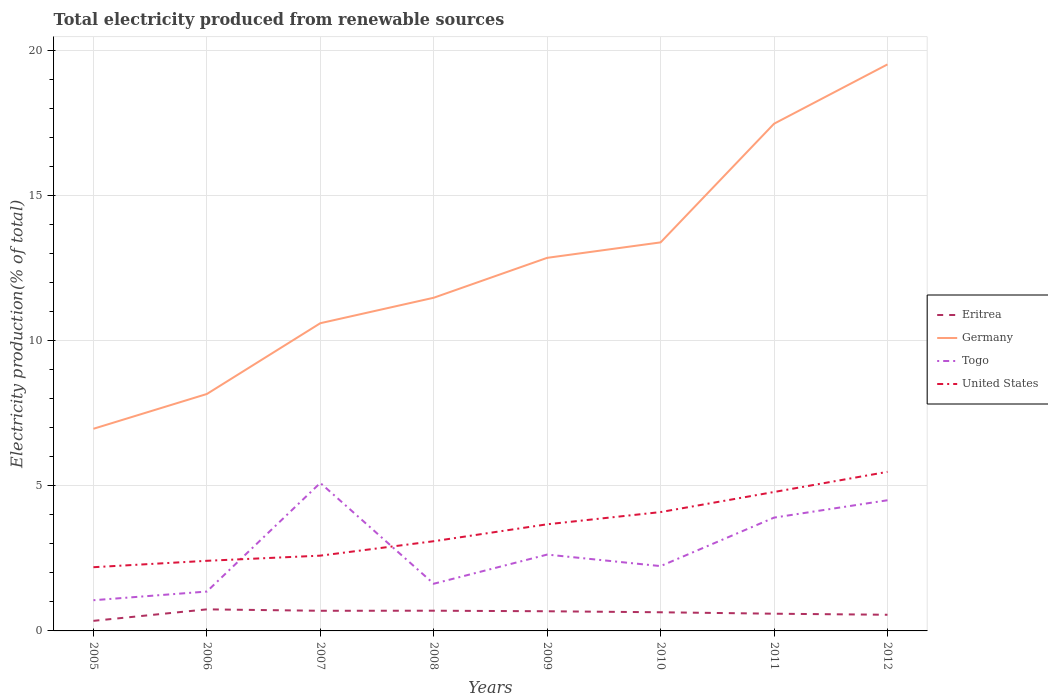Is the number of lines equal to the number of legend labels?
Make the answer very short. Yes. Across all years, what is the maximum total electricity produced in Germany?
Provide a short and direct response. 6.97. What is the total total electricity produced in Eritrea in the graph?
Provide a succinct answer. -0.35. What is the difference between the highest and the second highest total electricity produced in Eritrea?
Offer a terse response. 0.4. How many lines are there?
Ensure brevity in your answer.  4. What is the difference between two consecutive major ticks on the Y-axis?
Your answer should be compact. 5. Are the values on the major ticks of Y-axis written in scientific E-notation?
Provide a short and direct response. No. Does the graph contain any zero values?
Provide a short and direct response. No. How many legend labels are there?
Your answer should be compact. 4. What is the title of the graph?
Ensure brevity in your answer.  Total electricity produced from renewable sources. What is the label or title of the X-axis?
Offer a terse response. Years. What is the label or title of the Y-axis?
Make the answer very short. Electricity production(% of total). What is the Electricity production(% of total) of Eritrea in 2005?
Offer a terse response. 0.35. What is the Electricity production(% of total) in Germany in 2005?
Provide a short and direct response. 6.97. What is the Electricity production(% of total) in Togo in 2005?
Offer a terse response. 1.06. What is the Electricity production(% of total) of United States in 2005?
Offer a very short reply. 2.2. What is the Electricity production(% of total) in Eritrea in 2006?
Offer a very short reply. 0.74. What is the Electricity production(% of total) of Germany in 2006?
Provide a succinct answer. 8.17. What is the Electricity production(% of total) in Togo in 2006?
Ensure brevity in your answer.  1.36. What is the Electricity production(% of total) of United States in 2006?
Make the answer very short. 2.42. What is the Electricity production(% of total) of Eritrea in 2007?
Make the answer very short. 0.69. What is the Electricity production(% of total) of Germany in 2007?
Provide a succinct answer. 10.61. What is the Electricity production(% of total) of Togo in 2007?
Your answer should be very brief. 5.1. What is the Electricity production(% of total) of United States in 2007?
Keep it short and to the point. 2.59. What is the Electricity production(% of total) in Eritrea in 2008?
Ensure brevity in your answer.  0.7. What is the Electricity production(% of total) in Germany in 2008?
Your answer should be compact. 11.49. What is the Electricity production(% of total) in Togo in 2008?
Keep it short and to the point. 1.63. What is the Electricity production(% of total) in United States in 2008?
Keep it short and to the point. 3.09. What is the Electricity production(% of total) in Eritrea in 2009?
Your answer should be very brief. 0.68. What is the Electricity production(% of total) of Germany in 2009?
Provide a short and direct response. 12.86. What is the Electricity production(% of total) in Togo in 2009?
Your answer should be compact. 2.63. What is the Electricity production(% of total) in United States in 2009?
Offer a terse response. 3.68. What is the Electricity production(% of total) of Eritrea in 2010?
Ensure brevity in your answer.  0.64. What is the Electricity production(% of total) of Germany in 2010?
Make the answer very short. 13.39. What is the Electricity production(% of total) in Togo in 2010?
Provide a short and direct response. 2.23. What is the Electricity production(% of total) of United States in 2010?
Make the answer very short. 4.1. What is the Electricity production(% of total) of Eritrea in 2011?
Offer a very short reply. 0.59. What is the Electricity production(% of total) of Germany in 2011?
Offer a terse response. 17.48. What is the Electricity production(% of total) in Togo in 2011?
Your answer should be very brief. 3.91. What is the Electricity production(% of total) in United States in 2011?
Your response must be concise. 4.79. What is the Electricity production(% of total) of Eritrea in 2012?
Your answer should be very brief. 0.56. What is the Electricity production(% of total) of Germany in 2012?
Make the answer very short. 19.53. What is the Electricity production(% of total) of Togo in 2012?
Your answer should be compact. 4.5. What is the Electricity production(% of total) of United States in 2012?
Keep it short and to the point. 5.48. Across all years, what is the maximum Electricity production(% of total) of Eritrea?
Your response must be concise. 0.74. Across all years, what is the maximum Electricity production(% of total) of Germany?
Offer a very short reply. 19.53. Across all years, what is the maximum Electricity production(% of total) in Togo?
Make the answer very short. 5.1. Across all years, what is the maximum Electricity production(% of total) of United States?
Provide a short and direct response. 5.48. Across all years, what is the minimum Electricity production(% of total) in Eritrea?
Ensure brevity in your answer.  0.35. Across all years, what is the minimum Electricity production(% of total) of Germany?
Offer a terse response. 6.97. Across all years, what is the minimum Electricity production(% of total) of Togo?
Your answer should be very brief. 1.06. Across all years, what is the minimum Electricity production(% of total) of United States?
Offer a very short reply. 2.2. What is the total Electricity production(% of total) of Eritrea in the graph?
Make the answer very short. 4.95. What is the total Electricity production(% of total) of Germany in the graph?
Ensure brevity in your answer.  100.5. What is the total Electricity production(% of total) in Togo in the graph?
Provide a short and direct response. 22.42. What is the total Electricity production(% of total) in United States in the graph?
Provide a short and direct response. 28.35. What is the difference between the Electricity production(% of total) in Eritrea in 2005 and that in 2006?
Provide a short and direct response. -0.4. What is the difference between the Electricity production(% of total) of Germany in 2005 and that in 2006?
Offer a very short reply. -1.2. What is the difference between the Electricity production(% of total) in Togo in 2005 and that in 2006?
Ensure brevity in your answer.  -0.3. What is the difference between the Electricity production(% of total) in United States in 2005 and that in 2006?
Offer a terse response. -0.22. What is the difference between the Electricity production(% of total) of Eritrea in 2005 and that in 2007?
Give a very brief answer. -0.35. What is the difference between the Electricity production(% of total) of Germany in 2005 and that in 2007?
Your response must be concise. -3.64. What is the difference between the Electricity production(% of total) of Togo in 2005 and that in 2007?
Your answer should be very brief. -4.04. What is the difference between the Electricity production(% of total) in United States in 2005 and that in 2007?
Provide a short and direct response. -0.4. What is the difference between the Electricity production(% of total) in Eritrea in 2005 and that in 2008?
Provide a short and direct response. -0.35. What is the difference between the Electricity production(% of total) of Germany in 2005 and that in 2008?
Keep it short and to the point. -4.52. What is the difference between the Electricity production(% of total) in Togo in 2005 and that in 2008?
Give a very brief answer. -0.57. What is the difference between the Electricity production(% of total) of United States in 2005 and that in 2008?
Offer a very short reply. -0.9. What is the difference between the Electricity production(% of total) in Eritrea in 2005 and that in 2009?
Offer a very short reply. -0.33. What is the difference between the Electricity production(% of total) of Germany in 2005 and that in 2009?
Make the answer very short. -5.89. What is the difference between the Electricity production(% of total) of Togo in 2005 and that in 2009?
Your answer should be compact. -1.57. What is the difference between the Electricity production(% of total) in United States in 2005 and that in 2009?
Ensure brevity in your answer.  -1.48. What is the difference between the Electricity production(% of total) in Eritrea in 2005 and that in 2010?
Your answer should be very brief. -0.3. What is the difference between the Electricity production(% of total) in Germany in 2005 and that in 2010?
Make the answer very short. -6.43. What is the difference between the Electricity production(% of total) in Togo in 2005 and that in 2010?
Provide a succinct answer. -1.18. What is the difference between the Electricity production(% of total) of United States in 2005 and that in 2010?
Ensure brevity in your answer.  -1.9. What is the difference between the Electricity production(% of total) in Eritrea in 2005 and that in 2011?
Provide a short and direct response. -0.25. What is the difference between the Electricity production(% of total) of Germany in 2005 and that in 2011?
Keep it short and to the point. -10.52. What is the difference between the Electricity production(% of total) of Togo in 2005 and that in 2011?
Make the answer very short. -2.85. What is the difference between the Electricity production(% of total) of United States in 2005 and that in 2011?
Provide a short and direct response. -2.59. What is the difference between the Electricity production(% of total) of Eritrea in 2005 and that in 2012?
Keep it short and to the point. -0.21. What is the difference between the Electricity production(% of total) in Germany in 2005 and that in 2012?
Offer a very short reply. -12.56. What is the difference between the Electricity production(% of total) of Togo in 2005 and that in 2012?
Keep it short and to the point. -3.45. What is the difference between the Electricity production(% of total) of United States in 2005 and that in 2012?
Keep it short and to the point. -3.29. What is the difference between the Electricity production(% of total) of Eritrea in 2006 and that in 2007?
Keep it short and to the point. 0.05. What is the difference between the Electricity production(% of total) in Germany in 2006 and that in 2007?
Offer a very short reply. -2.44. What is the difference between the Electricity production(% of total) of Togo in 2006 and that in 2007?
Ensure brevity in your answer.  -3.74. What is the difference between the Electricity production(% of total) of United States in 2006 and that in 2007?
Offer a very short reply. -0.18. What is the difference between the Electricity production(% of total) of Eritrea in 2006 and that in 2008?
Make the answer very short. 0.05. What is the difference between the Electricity production(% of total) in Germany in 2006 and that in 2008?
Your answer should be very brief. -3.32. What is the difference between the Electricity production(% of total) of Togo in 2006 and that in 2008?
Provide a succinct answer. -0.27. What is the difference between the Electricity production(% of total) in United States in 2006 and that in 2008?
Your answer should be very brief. -0.68. What is the difference between the Electricity production(% of total) of Eritrea in 2006 and that in 2009?
Offer a terse response. 0.07. What is the difference between the Electricity production(% of total) of Germany in 2006 and that in 2009?
Your response must be concise. -4.69. What is the difference between the Electricity production(% of total) in Togo in 2006 and that in 2009?
Give a very brief answer. -1.27. What is the difference between the Electricity production(% of total) in United States in 2006 and that in 2009?
Ensure brevity in your answer.  -1.26. What is the difference between the Electricity production(% of total) in Eritrea in 2006 and that in 2010?
Give a very brief answer. 0.1. What is the difference between the Electricity production(% of total) of Germany in 2006 and that in 2010?
Give a very brief answer. -5.23. What is the difference between the Electricity production(% of total) of Togo in 2006 and that in 2010?
Make the answer very short. -0.88. What is the difference between the Electricity production(% of total) of United States in 2006 and that in 2010?
Give a very brief answer. -1.68. What is the difference between the Electricity production(% of total) of Eritrea in 2006 and that in 2011?
Your answer should be compact. 0.15. What is the difference between the Electricity production(% of total) in Germany in 2006 and that in 2011?
Keep it short and to the point. -9.32. What is the difference between the Electricity production(% of total) of Togo in 2006 and that in 2011?
Offer a very short reply. -2.55. What is the difference between the Electricity production(% of total) in United States in 2006 and that in 2011?
Offer a terse response. -2.37. What is the difference between the Electricity production(% of total) in Eritrea in 2006 and that in 2012?
Your response must be concise. 0.19. What is the difference between the Electricity production(% of total) in Germany in 2006 and that in 2012?
Keep it short and to the point. -11.36. What is the difference between the Electricity production(% of total) of Togo in 2006 and that in 2012?
Make the answer very short. -3.15. What is the difference between the Electricity production(% of total) of United States in 2006 and that in 2012?
Offer a very short reply. -3.07. What is the difference between the Electricity production(% of total) in Eritrea in 2007 and that in 2008?
Keep it short and to the point. -0. What is the difference between the Electricity production(% of total) of Germany in 2007 and that in 2008?
Keep it short and to the point. -0.88. What is the difference between the Electricity production(% of total) in Togo in 2007 and that in 2008?
Give a very brief answer. 3.48. What is the difference between the Electricity production(% of total) of United States in 2007 and that in 2008?
Give a very brief answer. -0.5. What is the difference between the Electricity production(% of total) in Eritrea in 2007 and that in 2009?
Your response must be concise. 0.02. What is the difference between the Electricity production(% of total) of Germany in 2007 and that in 2009?
Provide a short and direct response. -2.25. What is the difference between the Electricity production(% of total) in Togo in 2007 and that in 2009?
Your response must be concise. 2.47. What is the difference between the Electricity production(% of total) of United States in 2007 and that in 2009?
Keep it short and to the point. -1.08. What is the difference between the Electricity production(% of total) of Eritrea in 2007 and that in 2010?
Your answer should be compact. 0.05. What is the difference between the Electricity production(% of total) of Germany in 2007 and that in 2010?
Your response must be concise. -2.79. What is the difference between the Electricity production(% of total) of Togo in 2007 and that in 2010?
Provide a short and direct response. 2.87. What is the difference between the Electricity production(% of total) in United States in 2007 and that in 2010?
Your answer should be very brief. -1.5. What is the difference between the Electricity production(% of total) in Eritrea in 2007 and that in 2011?
Give a very brief answer. 0.1. What is the difference between the Electricity production(% of total) of Germany in 2007 and that in 2011?
Make the answer very short. -6.88. What is the difference between the Electricity production(% of total) in Togo in 2007 and that in 2011?
Provide a succinct answer. 1.2. What is the difference between the Electricity production(% of total) in United States in 2007 and that in 2011?
Keep it short and to the point. -2.19. What is the difference between the Electricity production(% of total) in Eritrea in 2007 and that in 2012?
Offer a terse response. 0.14. What is the difference between the Electricity production(% of total) of Germany in 2007 and that in 2012?
Keep it short and to the point. -8.92. What is the difference between the Electricity production(% of total) of Togo in 2007 and that in 2012?
Give a very brief answer. 0.6. What is the difference between the Electricity production(% of total) of United States in 2007 and that in 2012?
Make the answer very short. -2.89. What is the difference between the Electricity production(% of total) of Eritrea in 2008 and that in 2009?
Offer a very short reply. 0.02. What is the difference between the Electricity production(% of total) in Germany in 2008 and that in 2009?
Offer a very short reply. -1.38. What is the difference between the Electricity production(% of total) of Togo in 2008 and that in 2009?
Give a very brief answer. -1.01. What is the difference between the Electricity production(% of total) of United States in 2008 and that in 2009?
Keep it short and to the point. -0.58. What is the difference between the Electricity production(% of total) in Eritrea in 2008 and that in 2010?
Your answer should be compact. 0.05. What is the difference between the Electricity production(% of total) of Germany in 2008 and that in 2010?
Your answer should be very brief. -1.91. What is the difference between the Electricity production(% of total) in Togo in 2008 and that in 2010?
Provide a short and direct response. -0.61. What is the difference between the Electricity production(% of total) in United States in 2008 and that in 2010?
Offer a very short reply. -1. What is the difference between the Electricity production(% of total) in Eritrea in 2008 and that in 2011?
Your answer should be very brief. 0.1. What is the difference between the Electricity production(% of total) in Germany in 2008 and that in 2011?
Your answer should be very brief. -6. What is the difference between the Electricity production(% of total) of Togo in 2008 and that in 2011?
Offer a very short reply. -2.28. What is the difference between the Electricity production(% of total) of United States in 2008 and that in 2011?
Offer a terse response. -1.7. What is the difference between the Electricity production(% of total) in Eritrea in 2008 and that in 2012?
Ensure brevity in your answer.  0.14. What is the difference between the Electricity production(% of total) of Germany in 2008 and that in 2012?
Ensure brevity in your answer.  -8.04. What is the difference between the Electricity production(% of total) in Togo in 2008 and that in 2012?
Offer a terse response. -2.88. What is the difference between the Electricity production(% of total) of United States in 2008 and that in 2012?
Your response must be concise. -2.39. What is the difference between the Electricity production(% of total) in Eritrea in 2009 and that in 2010?
Offer a very short reply. 0.03. What is the difference between the Electricity production(% of total) in Germany in 2009 and that in 2010?
Your answer should be very brief. -0.53. What is the difference between the Electricity production(% of total) of Togo in 2009 and that in 2010?
Offer a terse response. 0.4. What is the difference between the Electricity production(% of total) in United States in 2009 and that in 2010?
Your answer should be compact. -0.42. What is the difference between the Electricity production(% of total) in Eritrea in 2009 and that in 2011?
Offer a terse response. 0.08. What is the difference between the Electricity production(% of total) of Germany in 2009 and that in 2011?
Your answer should be very brief. -4.62. What is the difference between the Electricity production(% of total) in Togo in 2009 and that in 2011?
Provide a succinct answer. -1.27. What is the difference between the Electricity production(% of total) in United States in 2009 and that in 2011?
Offer a very short reply. -1.11. What is the difference between the Electricity production(% of total) in Eritrea in 2009 and that in 2012?
Provide a succinct answer. 0.12. What is the difference between the Electricity production(% of total) of Germany in 2009 and that in 2012?
Provide a succinct answer. -6.67. What is the difference between the Electricity production(% of total) of Togo in 2009 and that in 2012?
Ensure brevity in your answer.  -1.87. What is the difference between the Electricity production(% of total) of United States in 2009 and that in 2012?
Your answer should be very brief. -1.81. What is the difference between the Electricity production(% of total) in Eritrea in 2010 and that in 2011?
Offer a terse response. 0.05. What is the difference between the Electricity production(% of total) in Germany in 2010 and that in 2011?
Make the answer very short. -4.09. What is the difference between the Electricity production(% of total) of Togo in 2010 and that in 2011?
Offer a very short reply. -1.67. What is the difference between the Electricity production(% of total) in United States in 2010 and that in 2011?
Offer a terse response. -0.69. What is the difference between the Electricity production(% of total) of Eritrea in 2010 and that in 2012?
Ensure brevity in your answer.  0.09. What is the difference between the Electricity production(% of total) in Germany in 2010 and that in 2012?
Offer a terse response. -6.14. What is the difference between the Electricity production(% of total) in Togo in 2010 and that in 2012?
Ensure brevity in your answer.  -2.27. What is the difference between the Electricity production(% of total) in United States in 2010 and that in 2012?
Offer a terse response. -1.39. What is the difference between the Electricity production(% of total) in Eritrea in 2011 and that in 2012?
Offer a terse response. 0.04. What is the difference between the Electricity production(% of total) of Germany in 2011 and that in 2012?
Your response must be concise. -2.05. What is the difference between the Electricity production(% of total) of Togo in 2011 and that in 2012?
Give a very brief answer. -0.6. What is the difference between the Electricity production(% of total) in United States in 2011 and that in 2012?
Provide a succinct answer. -0.69. What is the difference between the Electricity production(% of total) in Eritrea in 2005 and the Electricity production(% of total) in Germany in 2006?
Your answer should be very brief. -7.82. What is the difference between the Electricity production(% of total) in Eritrea in 2005 and the Electricity production(% of total) in Togo in 2006?
Your answer should be very brief. -1.01. What is the difference between the Electricity production(% of total) in Eritrea in 2005 and the Electricity production(% of total) in United States in 2006?
Make the answer very short. -2.07. What is the difference between the Electricity production(% of total) in Germany in 2005 and the Electricity production(% of total) in Togo in 2006?
Keep it short and to the point. 5.61. What is the difference between the Electricity production(% of total) in Germany in 2005 and the Electricity production(% of total) in United States in 2006?
Offer a very short reply. 4.55. What is the difference between the Electricity production(% of total) in Togo in 2005 and the Electricity production(% of total) in United States in 2006?
Your answer should be very brief. -1.36. What is the difference between the Electricity production(% of total) in Eritrea in 2005 and the Electricity production(% of total) in Germany in 2007?
Your answer should be compact. -10.26. What is the difference between the Electricity production(% of total) of Eritrea in 2005 and the Electricity production(% of total) of Togo in 2007?
Your answer should be very brief. -4.75. What is the difference between the Electricity production(% of total) of Eritrea in 2005 and the Electricity production(% of total) of United States in 2007?
Your answer should be compact. -2.25. What is the difference between the Electricity production(% of total) in Germany in 2005 and the Electricity production(% of total) in Togo in 2007?
Ensure brevity in your answer.  1.87. What is the difference between the Electricity production(% of total) in Germany in 2005 and the Electricity production(% of total) in United States in 2007?
Keep it short and to the point. 4.37. What is the difference between the Electricity production(% of total) of Togo in 2005 and the Electricity production(% of total) of United States in 2007?
Provide a succinct answer. -1.54. What is the difference between the Electricity production(% of total) in Eritrea in 2005 and the Electricity production(% of total) in Germany in 2008?
Give a very brief answer. -11.14. What is the difference between the Electricity production(% of total) in Eritrea in 2005 and the Electricity production(% of total) in Togo in 2008?
Offer a very short reply. -1.28. What is the difference between the Electricity production(% of total) in Eritrea in 2005 and the Electricity production(% of total) in United States in 2008?
Give a very brief answer. -2.75. What is the difference between the Electricity production(% of total) in Germany in 2005 and the Electricity production(% of total) in Togo in 2008?
Make the answer very short. 5.34. What is the difference between the Electricity production(% of total) of Germany in 2005 and the Electricity production(% of total) of United States in 2008?
Make the answer very short. 3.88. What is the difference between the Electricity production(% of total) of Togo in 2005 and the Electricity production(% of total) of United States in 2008?
Offer a terse response. -2.03. What is the difference between the Electricity production(% of total) in Eritrea in 2005 and the Electricity production(% of total) in Germany in 2009?
Your response must be concise. -12.51. What is the difference between the Electricity production(% of total) in Eritrea in 2005 and the Electricity production(% of total) in Togo in 2009?
Make the answer very short. -2.28. What is the difference between the Electricity production(% of total) of Eritrea in 2005 and the Electricity production(% of total) of United States in 2009?
Your response must be concise. -3.33. What is the difference between the Electricity production(% of total) in Germany in 2005 and the Electricity production(% of total) in Togo in 2009?
Make the answer very short. 4.34. What is the difference between the Electricity production(% of total) in Germany in 2005 and the Electricity production(% of total) in United States in 2009?
Offer a very short reply. 3.29. What is the difference between the Electricity production(% of total) of Togo in 2005 and the Electricity production(% of total) of United States in 2009?
Offer a very short reply. -2.62. What is the difference between the Electricity production(% of total) of Eritrea in 2005 and the Electricity production(% of total) of Germany in 2010?
Make the answer very short. -13.05. What is the difference between the Electricity production(% of total) of Eritrea in 2005 and the Electricity production(% of total) of Togo in 2010?
Keep it short and to the point. -1.89. What is the difference between the Electricity production(% of total) in Eritrea in 2005 and the Electricity production(% of total) in United States in 2010?
Your response must be concise. -3.75. What is the difference between the Electricity production(% of total) in Germany in 2005 and the Electricity production(% of total) in Togo in 2010?
Your answer should be compact. 4.73. What is the difference between the Electricity production(% of total) of Germany in 2005 and the Electricity production(% of total) of United States in 2010?
Keep it short and to the point. 2.87. What is the difference between the Electricity production(% of total) of Togo in 2005 and the Electricity production(% of total) of United States in 2010?
Ensure brevity in your answer.  -3.04. What is the difference between the Electricity production(% of total) of Eritrea in 2005 and the Electricity production(% of total) of Germany in 2011?
Offer a very short reply. -17.14. What is the difference between the Electricity production(% of total) in Eritrea in 2005 and the Electricity production(% of total) in Togo in 2011?
Provide a succinct answer. -3.56. What is the difference between the Electricity production(% of total) of Eritrea in 2005 and the Electricity production(% of total) of United States in 2011?
Make the answer very short. -4.44. What is the difference between the Electricity production(% of total) in Germany in 2005 and the Electricity production(% of total) in Togo in 2011?
Provide a short and direct response. 3.06. What is the difference between the Electricity production(% of total) of Germany in 2005 and the Electricity production(% of total) of United States in 2011?
Your answer should be compact. 2.18. What is the difference between the Electricity production(% of total) in Togo in 2005 and the Electricity production(% of total) in United States in 2011?
Provide a short and direct response. -3.73. What is the difference between the Electricity production(% of total) of Eritrea in 2005 and the Electricity production(% of total) of Germany in 2012?
Offer a very short reply. -19.18. What is the difference between the Electricity production(% of total) in Eritrea in 2005 and the Electricity production(% of total) in Togo in 2012?
Keep it short and to the point. -4.16. What is the difference between the Electricity production(% of total) in Eritrea in 2005 and the Electricity production(% of total) in United States in 2012?
Your answer should be compact. -5.14. What is the difference between the Electricity production(% of total) of Germany in 2005 and the Electricity production(% of total) of Togo in 2012?
Make the answer very short. 2.46. What is the difference between the Electricity production(% of total) of Germany in 2005 and the Electricity production(% of total) of United States in 2012?
Give a very brief answer. 1.48. What is the difference between the Electricity production(% of total) in Togo in 2005 and the Electricity production(% of total) in United States in 2012?
Provide a short and direct response. -4.43. What is the difference between the Electricity production(% of total) of Eritrea in 2006 and the Electricity production(% of total) of Germany in 2007?
Your answer should be very brief. -9.86. What is the difference between the Electricity production(% of total) of Eritrea in 2006 and the Electricity production(% of total) of Togo in 2007?
Give a very brief answer. -4.36. What is the difference between the Electricity production(% of total) of Eritrea in 2006 and the Electricity production(% of total) of United States in 2007?
Offer a very short reply. -1.85. What is the difference between the Electricity production(% of total) of Germany in 2006 and the Electricity production(% of total) of Togo in 2007?
Keep it short and to the point. 3.07. What is the difference between the Electricity production(% of total) of Germany in 2006 and the Electricity production(% of total) of United States in 2007?
Your response must be concise. 5.57. What is the difference between the Electricity production(% of total) of Togo in 2006 and the Electricity production(% of total) of United States in 2007?
Your answer should be very brief. -1.24. What is the difference between the Electricity production(% of total) in Eritrea in 2006 and the Electricity production(% of total) in Germany in 2008?
Ensure brevity in your answer.  -10.74. What is the difference between the Electricity production(% of total) of Eritrea in 2006 and the Electricity production(% of total) of Togo in 2008?
Keep it short and to the point. -0.88. What is the difference between the Electricity production(% of total) of Eritrea in 2006 and the Electricity production(% of total) of United States in 2008?
Ensure brevity in your answer.  -2.35. What is the difference between the Electricity production(% of total) of Germany in 2006 and the Electricity production(% of total) of Togo in 2008?
Your answer should be very brief. 6.54. What is the difference between the Electricity production(% of total) of Germany in 2006 and the Electricity production(% of total) of United States in 2008?
Keep it short and to the point. 5.08. What is the difference between the Electricity production(% of total) in Togo in 2006 and the Electricity production(% of total) in United States in 2008?
Offer a very short reply. -1.74. What is the difference between the Electricity production(% of total) of Eritrea in 2006 and the Electricity production(% of total) of Germany in 2009?
Offer a terse response. -12.12. What is the difference between the Electricity production(% of total) in Eritrea in 2006 and the Electricity production(% of total) in Togo in 2009?
Provide a short and direct response. -1.89. What is the difference between the Electricity production(% of total) of Eritrea in 2006 and the Electricity production(% of total) of United States in 2009?
Your response must be concise. -2.93. What is the difference between the Electricity production(% of total) of Germany in 2006 and the Electricity production(% of total) of Togo in 2009?
Give a very brief answer. 5.54. What is the difference between the Electricity production(% of total) of Germany in 2006 and the Electricity production(% of total) of United States in 2009?
Your answer should be compact. 4.49. What is the difference between the Electricity production(% of total) of Togo in 2006 and the Electricity production(% of total) of United States in 2009?
Your response must be concise. -2.32. What is the difference between the Electricity production(% of total) of Eritrea in 2006 and the Electricity production(% of total) of Germany in 2010?
Provide a succinct answer. -12.65. What is the difference between the Electricity production(% of total) in Eritrea in 2006 and the Electricity production(% of total) in Togo in 2010?
Your answer should be compact. -1.49. What is the difference between the Electricity production(% of total) of Eritrea in 2006 and the Electricity production(% of total) of United States in 2010?
Give a very brief answer. -3.35. What is the difference between the Electricity production(% of total) of Germany in 2006 and the Electricity production(% of total) of Togo in 2010?
Your answer should be very brief. 5.93. What is the difference between the Electricity production(% of total) in Germany in 2006 and the Electricity production(% of total) in United States in 2010?
Offer a very short reply. 4.07. What is the difference between the Electricity production(% of total) of Togo in 2006 and the Electricity production(% of total) of United States in 2010?
Offer a terse response. -2.74. What is the difference between the Electricity production(% of total) of Eritrea in 2006 and the Electricity production(% of total) of Germany in 2011?
Keep it short and to the point. -16.74. What is the difference between the Electricity production(% of total) in Eritrea in 2006 and the Electricity production(% of total) in Togo in 2011?
Your response must be concise. -3.16. What is the difference between the Electricity production(% of total) of Eritrea in 2006 and the Electricity production(% of total) of United States in 2011?
Provide a succinct answer. -4.05. What is the difference between the Electricity production(% of total) of Germany in 2006 and the Electricity production(% of total) of Togo in 2011?
Make the answer very short. 4.26. What is the difference between the Electricity production(% of total) of Germany in 2006 and the Electricity production(% of total) of United States in 2011?
Offer a terse response. 3.38. What is the difference between the Electricity production(% of total) of Togo in 2006 and the Electricity production(% of total) of United States in 2011?
Your answer should be very brief. -3.43. What is the difference between the Electricity production(% of total) in Eritrea in 2006 and the Electricity production(% of total) in Germany in 2012?
Your response must be concise. -18.79. What is the difference between the Electricity production(% of total) of Eritrea in 2006 and the Electricity production(% of total) of Togo in 2012?
Offer a terse response. -3.76. What is the difference between the Electricity production(% of total) in Eritrea in 2006 and the Electricity production(% of total) in United States in 2012?
Your answer should be very brief. -4.74. What is the difference between the Electricity production(% of total) of Germany in 2006 and the Electricity production(% of total) of Togo in 2012?
Give a very brief answer. 3.66. What is the difference between the Electricity production(% of total) of Germany in 2006 and the Electricity production(% of total) of United States in 2012?
Ensure brevity in your answer.  2.68. What is the difference between the Electricity production(% of total) in Togo in 2006 and the Electricity production(% of total) in United States in 2012?
Give a very brief answer. -4.13. What is the difference between the Electricity production(% of total) of Eritrea in 2007 and the Electricity production(% of total) of Germany in 2008?
Your response must be concise. -10.79. What is the difference between the Electricity production(% of total) in Eritrea in 2007 and the Electricity production(% of total) in Togo in 2008?
Provide a short and direct response. -0.93. What is the difference between the Electricity production(% of total) in Eritrea in 2007 and the Electricity production(% of total) in United States in 2008?
Your answer should be very brief. -2.4. What is the difference between the Electricity production(% of total) in Germany in 2007 and the Electricity production(% of total) in Togo in 2008?
Your response must be concise. 8.98. What is the difference between the Electricity production(% of total) in Germany in 2007 and the Electricity production(% of total) in United States in 2008?
Offer a terse response. 7.52. What is the difference between the Electricity production(% of total) of Togo in 2007 and the Electricity production(% of total) of United States in 2008?
Keep it short and to the point. 2.01. What is the difference between the Electricity production(% of total) in Eritrea in 2007 and the Electricity production(% of total) in Germany in 2009?
Offer a very short reply. -12.17. What is the difference between the Electricity production(% of total) in Eritrea in 2007 and the Electricity production(% of total) in Togo in 2009?
Make the answer very short. -1.94. What is the difference between the Electricity production(% of total) of Eritrea in 2007 and the Electricity production(% of total) of United States in 2009?
Offer a terse response. -2.98. What is the difference between the Electricity production(% of total) in Germany in 2007 and the Electricity production(% of total) in Togo in 2009?
Your answer should be compact. 7.98. What is the difference between the Electricity production(% of total) of Germany in 2007 and the Electricity production(% of total) of United States in 2009?
Your response must be concise. 6.93. What is the difference between the Electricity production(% of total) in Togo in 2007 and the Electricity production(% of total) in United States in 2009?
Your answer should be very brief. 1.43. What is the difference between the Electricity production(% of total) of Eritrea in 2007 and the Electricity production(% of total) of Germany in 2010?
Give a very brief answer. -12.7. What is the difference between the Electricity production(% of total) in Eritrea in 2007 and the Electricity production(% of total) in Togo in 2010?
Offer a terse response. -1.54. What is the difference between the Electricity production(% of total) of Eritrea in 2007 and the Electricity production(% of total) of United States in 2010?
Make the answer very short. -3.4. What is the difference between the Electricity production(% of total) of Germany in 2007 and the Electricity production(% of total) of Togo in 2010?
Your answer should be very brief. 8.37. What is the difference between the Electricity production(% of total) in Germany in 2007 and the Electricity production(% of total) in United States in 2010?
Ensure brevity in your answer.  6.51. What is the difference between the Electricity production(% of total) in Togo in 2007 and the Electricity production(% of total) in United States in 2010?
Your response must be concise. 1. What is the difference between the Electricity production(% of total) in Eritrea in 2007 and the Electricity production(% of total) in Germany in 2011?
Your response must be concise. -16.79. What is the difference between the Electricity production(% of total) of Eritrea in 2007 and the Electricity production(% of total) of Togo in 2011?
Offer a terse response. -3.21. What is the difference between the Electricity production(% of total) of Eritrea in 2007 and the Electricity production(% of total) of United States in 2011?
Offer a terse response. -4.09. What is the difference between the Electricity production(% of total) in Germany in 2007 and the Electricity production(% of total) in Togo in 2011?
Make the answer very short. 6.7. What is the difference between the Electricity production(% of total) in Germany in 2007 and the Electricity production(% of total) in United States in 2011?
Offer a terse response. 5.82. What is the difference between the Electricity production(% of total) in Togo in 2007 and the Electricity production(% of total) in United States in 2011?
Make the answer very short. 0.31. What is the difference between the Electricity production(% of total) of Eritrea in 2007 and the Electricity production(% of total) of Germany in 2012?
Give a very brief answer. -18.84. What is the difference between the Electricity production(% of total) of Eritrea in 2007 and the Electricity production(% of total) of Togo in 2012?
Make the answer very short. -3.81. What is the difference between the Electricity production(% of total) in Eritrea in 2007 and the Electricity production(% of total) in United States in 2012?
Your answer should be compact. -4.79. What is the difference between the Electricity production(% of total) in Germany in 2007 and the Electricity production(% of total) in Togo in 2012?
Offer a very short reply. 6.1. What is the difference between the Electricity production(% of total) of Germany in 2007 and the Electricity production(% of total) of United States in 2012?
Your response must be concise. 5.12. What is the difference between the Electricity production(% of total) of Togo in 2007 and the Electricity production(% of total) of United States in 2012?
Your response must be concise. -0.38. What is the difference between the Electricity production(% of total) of Eritrea in 2008 and the Electricity production(% of total) of Germany in 2009?
Keep it short and to the point. -12.16. What is the difference between the Electricity production(% of total) of Eritrea in 2008 and the Electricity production(% of total) of Togo in 2009?
Your answer should be compact. -1.93. What is the difference between the Electricity production(% of total) in Eritrea in 2008 and the Electricity production(% of total) in United States in 2009?
Offer a terse response. -2.98. What is the difference between the Electricity production(% of total) of Germany in 2008 and the Electricity production(% of total) of Togo in 2009?
Make the answer very short. 8.85. What is the difference between the Electricity production(% of total) in Germany in 2008 and the Electricity production(% of total) in United States in 2009?
Provide a succinct answer. 7.81. What is the difference between the Electricity production(% of total) of Togo in 2008 and the Electricity production(% of total) of United States in 2009?
Provide a succinct answer. -2.05. What is the difference between the Electricity production(% of total) in Eritrea in 2008 and the Electricity production(% of total) in Germany in 2010?
Ensure brevity in your answer.  -12.7. What is the difference between the Electricity production(% of total) in Eritrea in 2008 and the Electricity production(% of total) in Togo in 2010?
Your response must be concise. -1.54. What is the difference between the Electricity production(% of total) of Eritrea in 2008 and the Electricity production(% of total) of United States in 2010?
Provide a short and direct response. -3.4. What is the difference between the Electricity production(% of total) of Germany in 2008 and the Electricity production(% of total) of Togo in 2010?
Offer a very short reply. 9.25. What is the difference between the Electricity production(% of total) in Germany in 2008 and the Electricity production(% of total) in United States in 2010?
Ensure brevity in your answer.  7.39. What is the difference between the Electricity production(% of total) in Togo in 2008 and the Electricity production(% of total) in United States in 2010?
Offer a very short reply. -2.47. What is the difference between the Electricity production(% of total) in Eritrea in 2008 and the Electricity production(% of total) in Germany in 2011?
Ensure brevity in your answer.  -16.79. What is the difference between the Electricity production(% of total) of Eritrea in 2008 and the Electricity production(% of total) of Togo in 2011?
Your answer should be compact. -3.21. What is the difference between the Electricity production(% of total) of Eritrea in 2008 and the Electricity production(% of total) of United States in 2011?
Provide a succinct answer. -4.09. What is the difference between the Electricity production(% of total) of Germany in 2008 and the Electricity production(% of total) of Togo in 2011?
Make the answer very short. 7.58. What is the difference between the Electricity production(% of total) of Germany in 2008 and the Electricity production(% of total) of United States in 2011?
Provide a succinct answer. 6.7. What is the difference between the Electricity production(% of total) in Togo in 2008 and the Electricity production(% of total) in United States in 2011?
Offer a terse response. -3.16. What is the difference between the Electricity production(% of total) of Eritrea in 2008 and the Electricity production(% of total) of Germany in 2012?
Offer a terse response. -18.83. What is the difference between the Electricity production(% of total) in Eritrea in 2008 and the Electricity production(% of total) in Togo in 2012?
Offer a terse response. -3.81. What is the difference between the Electricity production(% of total) of Eritrea in 2008 and the Electricity production(% of total) of United States in 2012?
Make the answer very short. -4.79. What is the difference between the Electricity production(% of total) in Germany in 2008 and the Electricity production(% of total) in Togo in 2012?
Keep it short and to the point. 6.98. What is the difference between the Electricity production(% of total) of Germany in 2008 and the Electricity production(% of total) of United States in 2012?
Your answer should be compact. 6. What is the difference between the Electricity production(% of total) in Togo in 2008 and the Electricity production(% of total) in United States in 2012?
Provide a short and direct response. -3.86. What is the difference between the Electricity production(% of total) of Eritrea in 2009 and the Electricity production(% of total) of Germany in 2010?
Provide a short and direct response. -12.72. What is the difference between the Electricity production(% of total) in Eritrea in 2009 and the Electricity production(% of total) in Togo in 2010?
Ensure brevity in your answer.  -1.56. What is the difference between the Electricity production(% of total) of Eritrea in 2009 and the Electricity production(% of total) of United States in 2010?
Keep it short and to the point. -3.42. What is the difference between the Electricity production(% of total) of Germany in 2009 and the Electricity production(% of total) of Togo in 2010?
Ensure brevity in your answer.  10.63. What is the difference between the Electricity production(% of total) of Germany in 2009 and the Electricity production(% of total) of United States in 2010?
Ensure brevity in your answer.  8.76. What is the difference between the Electricity production(% of total) of Togo in 2009 and the Electricity production(% of total) of United States in 2010?
Offer a terse response. -1.47. What is the difference between the Electricity production(% of total) of Eritrea in 2009 and the Electricity production(% of total) of Germany in 2011?
Keep it short and to the point. -16.81. What is the difference between the Electricity production(% of total) of Eritrea in 2009 and the Electricity production(% of total) of Togo in 2011?
Offer a very short reply. -3.23. What is the difference between the Electricity production(% of total) of Eritrea in 2009 and the Electricity production(% of total) of United States in 2011?
Provide a short and direct response. -4.11. What is the difference between the Electricity production(% of total) of Germany in 2009 and the Electricity production(% of total) of Togo in 2011?
Your response must be concise. 8.96. What is the difference between the Electricity production(% of total) of Germany in 2009 and the Electricity production(% of total) of United States in 2011?
Keep it short and to the point. 8.07. What is the difference between the Electricity production(% of total) of Togo in 2009 and the Electricity production(% of total) of United States in 2011?
Your answer should be compact. -2.16. What is the difference between the Electricity production(% of total) in Eritrea in 2009 and the Electricity production(% of total) in Germany in 2012?
Your answer should be compact. -18.85. What is the difference between the Electricity production(% of total) of Eritrea in 2009 and the Electricity production(% of total) of Togo in 2012?
Your answer should be very brief. -3.83. What is the difference between the Electricity production(% of total) in Eritrea in 2009 and the Electricity production(% of total) in United States in 2012?
Ensure brevity in your answer.  -4.81. What is the difference between the Electricity production(% of total) of Germany in 2009 and the Electricity production(% of total) of Togo in 2012?
Keep it short and to the point. 8.36. What is the difference between the Electricity production(% of total) of Germany in 2009 and the Electricity production(% of total) of United States in 2012?
Your answer should be compact. 7.38. What is the difference between the Electricity production(% of total) in Togo in 2009 and the Electricity production(% of total) in United States in 2012?
Keep it short and to the point. -2.85. What is the difference between the Electricity production(% of total) in Eritrea in 2010 and the Electricity production(% of total) in Germany in 2011?
Your response must be concise. -16.84. What is the difference between the Electricity production(% of total) of Eritrea in 2010 and the Electricity production(% of total) of Togo in 2011?
Give a very brief answer. -3.26. What is the difference between the Electricity production(% of total) in Eritrea in 2010 and the Electricity production(% of total) in United States in 2011?
Offer a very short reply. -4.15. What is the difference between the Electricity production(% of total) in Germany in 2010 and the Electricity production(% of total) in Togo in 2011?
Give a very brief answer. 9.49. What is the difference between the Electricity production(% of total) of Germany in 2010 and the Electricity production(% of total) of United States in 2011?
Provide a succinct answer. 8.61. What is the difference between the Electricity production(% of total) in Togo in 2010 and the Electricity production(% of total) in United States in 2011?
Keep it short and to the point. -2.55. What is the difference between the Electricity production(% of total) in Eritrea in 2010 and the Electricity production(% of total) in Germany in 2012?
Offer a very short reply. -18.89. What is the difference between the Electricity production(% of total) of Eritrea in 2010 and the Electricity production(% of total) of Togo in 2012?
Your answer should be compact. -3.86. What is the difference between the Electricity production(% of total) in Eritrea in 2010 and the Electricity production(% of total) in United States in 2012?
Provide a short and direct response. -4.84. What is the difference between the Electricity production(% of total) in Germany in 2010 and the Electricity production(% of total) in Togo in 2012?
Offer a very short reply. 8.89. What is the difference between the Electricity production(% of total) in Germany in 2010 and the Electricity production(% of total) in United States in 2012?
Your answer should be compact. 7.91. What is the difference between the Electricity production(% of total) in Togo in 2010 and the Electricity production(% of total) in United States in 2012?
Ensure brevity in your answer.  -3.25. What is the difference between the Electricity production(% of total) in Eritrea in 2011 and the Electricity production(% of total) in Germany in 2012?
Offer a terse response. -18.94. What is the difference between the Electricity production(% of total) in Eritrea in 2011 and the Electricity production(% of total) in Togo in 2012?
Ensure brevity in your answer.  -3.91. What is the difference between the Electricity production(% of total) in Eritrea in 2011 and the Electricity production(% of total) in United States in 2012?
Provide a short and direct response. -4.89. What is the difference between the Electricity production(% of total) of Germany in 2011 and the Electricity production(% of total) of Togo in 2012?
Your response must be concise. 12.98. What is the difference between the Electricity production(% of total) of Germany in 2011 and the Electricity production(% of total) of United States in 2012?
Ensure brevity in your answer.  12. What is the difference between the Electricity production(% of total) of Togo in 2011 and the Electricity production(% of total) of United States in 2012?
Ensure brevity in your answer.  -1.58. What is the average Electricity production(% of total) in Eritrea per year?
Make the answer very short. 0.62. What is the average Electricity production(% of total) in Germany per year?
Your answer should be very brief. 12.56. What is the average Electricity production(% of total) in Togo per year?
Provide a succinct answer. 2.8. What is the average Electricity production(% of total) in United States per year?
Keep it short and to the point. 3.54. In the year 2005, what is the difference between the Electricity production(% of total) of Eritrea and Electricity production(% of total) of Germany?
Offer a terse response. -6.62. In the year 2005, what is the difference between the Electricity production(% of total) in Eritrea and Electricity production(% of total) in Togo?
Your answer should be compact. -0.71. In the year 2005, what is the difference between the Electricity production(% of total) in Eritrea and Electricity production(% of total) in United States?
Ensure brevity in your answer.  -1.85. In the year 2005, what is the difference between the Electricity production(% of total) in Germany and Electricity production(% of total) in Togo?
Your response must be concise. 5.91. In the year 2005, what is the difference between the Electricity production(% of total) in Germany and Electricity production(% of total) in United States?
Make the answer very short. 4.77. In the year 2005, what is the difference between the Electricity production(% of total) of Togo and Electricity production(% of total) of United States?
Your response must be concise. -1.14. In the year 2006, what is the difference between the Electricity production(% of total) in Eritrea and Electricity production(% of total) in Germany?
Your answer should be compact. -7.42. In the year 2006, what is the difference between the Electricity production(% of total) in Eritrea and Electricity production(% of total) in Togo?
Offer a very short reply. -0.61. In the year 2006, what is the difference between the Electricity production(% of total) of Eritrea and Electricity production(% of total) of United States?
Your answer should be very brief. -1.67. In the year 2006, what is the difference between the Electricity production(% of total) in Germany and Electricity production(% of total) in Togo?
Give a very brief answer. 6.81. In the year 2006, what is the difference between the Electricity production(% of total) of Germany and Electricity production(% of total) of United States?
Provide a succinct answer. 5.75. In the year 2006, what is the difference between the Electricity production(% of total) in Togo and Electricity production(% of total) in United States?
Offer a very short reply. -1.06. In the year 2007, what is the difference between the Electricity production(% of total) in Eritrea and Electricity production(% of total) in Germany?
Make the answer very short. -9.91. In the year 2007, what is the difference between the Electricity production(% of total) in Eritrea and Electricity production(% of total) in Togo?
Keep it short and to the point. -4.41. In the year 2007, what is the difference between the Electricity production(% of total) in Eritrea and Electricity production(% of total) in United States?
Keep it short and to the point. -1.9. In the year 2007, what is the difference between the Electricity production(% of total) in Germany and Electricity production(% of total) in Togo?
Ensure brevity in your answer.  5.51. In the year 2007, what is the difference between the Electricity production(% of total) of Germany and Electricity production(% of total) of United States?
Offer a terse response. 8.01. In the year 2007, what is the difference between the Electricity production(% of total) in Togo and Electricity production(% of total) in United States?
Provide a succinct answer. 2.51. In the year 2008, what is the difference between the Electricity production(% of total) of Eritrea and Electricity production(% of total) of Germany?
Provide a short and direct response. -10.79. In the year 2008, what is the difference between the Electricity production(% of total) in Eritrea and Electricity production(% of total) in Togo?
Keep it short and to the point. -0.93. In the year 2008, what is the difference between the Electricity production(% of total) of Eritrea and Electricity production(% of total) of United States?
Offer a terse response. -2.4. In the year 2008, what is the difference between the Electricity production(% of total) of Germany and Electricity production(% of total) of Togo?
Make the answer very short. 9.86. In the year 2008, what is the difference between the Electricity production(% of total) in Germany and Electricity production(% of total) in United States?
Make the answer very short. 8.39. In the year 2008, what is the difference between the Electricity production(% of total) in Togo and Electricity production(% of total) in United States?
Your answer should be compact. -1.47. In the year 2009, what is the difference between the Electricity production(% of total) of Eritrea and Electricity production(% of total) of Germany?
Your response must be concise. -12.18. In the year 2009, what is the difference between the Electricity production(% of total) of Eritrea and Electricity production(% of total) of Togo?
Give a very brief answer. -1.95. In the year 2009, what is the difference between the Electricity production(% of total) of Eritrea and Electricity production(% of total) of United States?
Provide a short and direct response. -3. In the year 2009, what is the difference between the Electricity production(% of total) of Germany and Electricity production(% of total) of Togo?
Provide a short and direct response. 10.23. In the year 2009, what is the difference between the Electricity production(% of total) in Germany and Electricity production(% of total) in United States?
Ensure brevity in your answer.  9.19. In the year 2009, what is the difference between the Electricity production(% of total) in Togo and Electricity production(% of total) in United States?
Keep it short and to the point. -1.04. In the year 2010, what is the difference between the Electricity production(% of total) of Eritrea and Electricity production(% of total) of Germany?
Offer a very short reply. -12.75. In the year 2010, what is the difference between the Electricity production(% of total) of Eritrea and Electricity production(% of total) of Togo?
Ensure brevity in your answer.  -1.59. In the year 2010, what is the difference between the Electricity production(% of total) of Eritrea and Electricity production(% of total) of United States?
Provide a succinct answer. -3.45. In the year 2010, what is the difference between the Electricity production(% of total) in Germany and Electricity production(% of total) in Togo?
Make the answer very short. 11.16. In the year 2010, what is the difference between the Electricity production(% of total) of Germany and Electricity production(% of total) of United States?
Offer a terse response. 9.3. In the year 2010, what is the difference between the Electricity production(% of total) of Togo and Electricity production(% of total) of United States?
Give a very brief answer. -1.86. In the year 2011, what is the difference between the Electricity production(% of total) in Eritrea and Electricity production(% of total) in Germany?
Ensure brevity in your answer.  -16.89. In the year 2011, what is the difference between the Electricity production(% of total) of Eritrea and Electricity production(% of total) of Togo?
Your answer should be very brief. -3.31. In the year 2011, what is the difference between the Electricity production(% of total) of Eritrea and Electricity production(% of total) of United States?
Make the answer very short. -4.2. In the year 2011, what is the difference between the Electricity production(% of total) in Germany and Electricity production(% of total) in Togo?
Your answer should be compact. 13.58. In the year 2011, what is the difference between the Electricity production(% of total) of Germany and Electricity production(% of total) of United States?
Your answer should be compact. 12.7. In the year 2011, what is the difference between the Electricity production(% of total) in Togo and Electricity production(% of total) in United States?
Your response must be concise. -0.88. In the year 2012, what is the difference between the Electricity production(% of total) in Eritrea and Electricity production(% of total) in Germany?
Your answer should be compact. -18.97. In the year 2012, what is the difference between the Electricity production(% of total) of Eritrea and Electricity production(% of total) of Togo?
Your response must be concise. -3.95. In the year 2012, what is the difference between the Electricity production(% of total) in Eritrea and Electricity production(% of total) in United States?
Make the answer very short. -4.93. In the year 2012, what is the difference between the Electricity production(% of total) in Germany and Electricity production(% of total) in Togo?
Keep it short and to the point. 15.03. In the year 2012, what is the difference between the Electricity production(% of total) of Germany and Electricity production(% of total) of United States?
Give a very brief answer. 14.05. In the year 2012, what is the difference between the Electricity production(% of total) in Togo and Electricity production(% of total) in United States?
Offer a terse response. -0.98. What is the ratio of the Electricity production(% of total) of Eritrea in 2005 to that in 2006?
Keep it short and to the point. 0.47. What is the ratio of the Electricity production(% of total) of Germany in 2005 to that in 2006?
Make the answer very short. 0.85. What is the ratio of the Electricity production(% of total) in Togo in 2005 to that in 2006?
Your answer should be very brief. 0.78. What is the ratio of the Electricity production(% of total) in United States in 2005 to that in 2006?
Provide a short and direct response. 0.91. What is the ratio of the Electricity production(% of total) in Germany in 2005 to that in 2007?
Give a very brief answer. 0.66. What is the ratio of the Electricity production(% of total) in Togo in 2005 to that in 2007?
Give a very brief answer. 0.21. What is the ratio of the Electricity production(% of total) of United States in 2005 to that in 2007?
Ensure brevity in your answer.  0.85. What is the ratio of the Electricity production(% of total) in Eritrea in 2005 to that in 2008?
Provide a succinct answer. 0.5. What is the ratio of the Electricity production(% of total) of Germany in 2005 to that in 2008?
Offer a very short reply. 0.61. What is the ratio of the Electricity production(% of total) in Togo in 2005 to that in 2008?
Make the answer very short. 0.65. What is the ratio of the Electricity production(% of total) of United States in 2005 to that in 2008?
Provide a short and direct response. 0.71. What is the ratio of the Electricity production(% of total) of Eritrea in 2005 to that in 2009?
Give a very brief answer. 0.51. What is the ratio of the Electricity production(% of total) of Germany in 2005 to that in 2009?
Offer a very short reply. 0.54. What is the ratio of the Electricity production(% of total) of Togo in 2005 to that in 2009?
Provide a short and direct response. 0.4. What is the ratio of the Electricity production(% of total) of United States in 2005 to that in 2009?
Your answer should be very brief. 0.6. What is the ratio of the Electricity production(% of total) of Eritrea in 2005 to that in 2010?
Make the answer very short. 0.54. What is the ratio of the Electricity production(% of total) in Germany in 2005 to that in 2010?
Give a very brief answer. 0.52. What is the ratio of the Electricity production(% of total) in Togo in 2005 to that in 2010?
Provide a succinct answer. 0.47. What is the ratio of the Electricity production(% of total) in United States in 2005 to that in 2010?
Provide a succinct answer. 0.54. What is the ratio of the Electricity production(% of total) in Eritrea in 2005 to that in 2011?
Provide a short and direct response. 0.59. What is the ratio of the Electricity production(% of total) in Germany in 2005 to that in 2011?
Your response must be concise. 0.4. What is the ratio of the Electricity production(% of total) of Togo in 2005 to that in 2011?
Ensure brevity in your answer.  0.27. What is the ratio of the Electricity production(% of total) of United States in 2005 to that in 2011?
Your response must be concise. 0.46. What is the ratio of the Electricity production(% of total) of Eritrea in 2005 to that in 2012?
Provide a succinct answer. 0.62. What is the ratio of the Electricity production(% of total) of Germany in 2005 to that in 2012?
Offer a very short reply. 0.36. What is the ratio of the Electricity production(% of total) in Togo in 2005 to that in 2012?
Your answer should be compact. 0.23. What is the ratio of the Electricity production(% of total) in United States in 2005 to that in 2012?
Offer a very short reply. 0.4. What is the ratio of the Electricity production(% of total) in Eritrea in 2006 to that in 2007?
Keep it short and to the point. 1.07. What is the ratio of the Electricity production(% of total) in Germany in 2006 to that in 2007?
Make the answer very short. 0.77. What is the ratio of the Electricity production(% of total) of Togo in 2006 to that in 2007?
Give a very brief answer. 0.27. What is the ratio of the Electricity production(% of total) in United States in 2006 to that in 2007?
Ensure brevity in your answer.  0.93. What is the ratio of the Electricity production(% of total) of Eritrea in 2006 to that in 2008?
Your response must be concise. 1.07. What is the ratio of the Electricity production(% of total) of Germany in 2006 to that in 2008?
Give a very brief answer. 0.71. What is the ratio of the Electricity production(% of total) of Togo in 2006 to that in 2008?
Offer a very short reply. 0.83. What is the ratio of the Electricity production(% of total) of United States in 2006 to that in 2008?
Ensure brevity in your answer.  0.78. What is the ratio of the Electricity production(% of total) in Eritrea in 2006 to that in 2009?
Your response must be concise. 1.1. What is the ratio of the Electricity production(% of total) in Germany in 2006 to that in 2009?
Make the answer very short. 0.64. What is the ratio of the Electricity production(% of total) in Togo in 2006 to that in 2009?
Offer a terse response. 0.52. What is the ratio of the Electricity production(% of total) of United States in 2006 to that in 2009?
Offer a very short reply. 0.66. What is the ratio of the Electricity production(% of total) in Eritrea in 2006 to that in 2010?
Provide a short and direct response. 1.16. What is the ratio of the Electricity production(% of total) of Germany in 2006 to that in 2010?
Provide a short and direct response. 0.61. What is the ratio of the Electricity production(% of total) of Togo in 2006 to that in 2010?
Your response must be concise. 0.61. What is the ratio of the Electricity production(% of total) in United States in 2006 to that in 2010?
Your answer should be compact. 0.59. What is the ratio of the Electricity production(% of total) of Eritrea in 2006 to that in 2011?
Your response must be concise. 1.25. What is the ratio of the Electricity production(% of total) in Germany in 2006 to that in 2011?
Offer a terse response. 0.47. What is the ratio of the Electricity production(% of total) in Togo in 2006 to that in 2011?
Your answer should be very brief. 0.35. What is the ratio of the Electricity production(% of total) in United States in 2006 to that in 2011?
Provide a short and direct response. 0.5. What is the ratio of the Electricity production(% of total) in Eritrea in 2006 to that in 2012?
Provide a succinct answer. 1.33. What is the ratio of the Electricity production(% of total) in Germany in 2006 to that in 2012?
Keep it short and to the point. 0.42. What is the ratio of the Electricity production(% of total) of Togo in 2006 to that in 2012?
Keep it short and to the point. 0.3. What is the ratio of the Electricity production(% of total) of United States in 2006 to that in 2012?
Your answer should be very brief. 0.44. What is the ratio of the Electricity production(% of total) in Germany in 2007 to that in 2008?
Your answer should be very brief. 0.92. What is the ratio of the Electricity production(% of total) of Togo in 2007 to that in 2008?
Your answer should be compact. 3.14. What is the ratio of the Electricity production(% of total) in United States in 2007 to that in 2008?
Offer a very short reply. 0.84. What is the ratio of the Electricity production(% of total) in Eritrea in 2007 to that in 2009?
Give a very brief answer. 1.02. What is the ratio of the Electricity production(% of total) in Germany in 2007 to that in 2009?
Provide a short and direct response. 0.82. What is the ratio of the Electricity production(% of total) in Togo in 2007 to that in 2009?
Ensure brevity in your answer.  1.94. What is the ratio of the Electricity production(% of total) in United States in 2007 to that in 2009?
Your response must be concise. 0.71. What is the ratio of the Electricity production(% of total) of Eritrea in 2007 to that in 2010?
Keep it short and to the point. 1.08. What is the ratio of the Electricity production(% of total) in Germany in 2007 to that in 2010?
Give a very brief answer. 0.79. What is the ratio of the Electricity production(% of total) of Togo in 2007 to that in 2010?
Give a very brief answer. 2.28. What is the ratio of the Electricity production(% of total) in United States in 2007 to that in 2010?
Keep it short and to the point. 0.63. What is the ratio of the Electricity production(% of total) of Eritrea in 2007 to that in 2011?
Your answer should be very brief. 1.17. What is the ratio of the Electricity production(% of total) of Germany in 2007 to that in 2011?
Keep it short and to the point. 0.61. What is the ratio of the Electricity production(% of total) of Togo in 2007 to that in 2011?
Make the answer very short. 1.31. What is the ratio of the Electricity production(% of total) in United States in 2007 to that in 2011?
Provide a succinct answer. 0.54. What is the ratio of the Electricity production(% of total) in Eritrea in 2007 to that in 2012?
Offer a very short reply. 1.25. What is the ratio of the Electricity production(% of total) in Germany in 2007 to that in 2012?
Ensure brevity in your answer.  0.54. What is the ratio of the Electricity production(% of total) of Togo in 2007 to that in 2012?
Provide a short and direct response. 1.13. What is the ratio of the Electricity production(% of total) of United States in 2007 to that in 2012?
Provide a succinct answer. 0.47. What is the ratio of the Electricity production(% of total) in Eritrea in 2008 to that in 2009?
Provide a short and direct response. 1.03. What is the ratio of the Electricity production(% of total) of Germany in 2008 to that in 2009?
Make the answer very short. 0.89. What is the ratio of the Electricity production(% of total) in Togo in 2008 to that in 2009?
Provide a short and direct response. 0.62. What is the ratio of the Electricity production(% of total) in United States in 2008 to that in 2009?
Offer a terse response. 0.84. What is the ratio of the Electricity production(% of total) in Eritrea in 2008 to that in 2010?
Your answer should be compact. 1.08. What is the ratio of the Electricity production(% of total) of Germany in 2008 to that in 2010?
Your answer should be compact. 0.86. What is the ratio of the Electricity production(% of total) of Togo in 2008 to that in 2010?
Provide a short and direct response. 0.73. What is the ratio of the Electricity production(% of total) of United States in 2008 to that in 2010?
Your answer should be very brief. 0.75. What is the ratio of the Electricity production(% of total) of Eritrea in 2008 to that in 2011?
Your answer should be compact. 1.17. What is the ratio of the Electricity production(% of total) in Germany in 2008 to that in 2011?
Make the answer very short. 0.66. What is the ratio of the Electricity production(% of total) in Togo in 2008 to that in 2011?
Give a very brief answer. 0.42. What is the ratio of the Electricity production(% of total) in United States in 2008 to that in 2011?
Provide a short and direct response. 0.65. What is the ratio of the Electricity production(% of total) of Eritrea in 2008 to that in 2012?
Keep it short and to the point. 1.25. What is the ratio of the Electricity production(% of total) of Germany in 2008 to that in 2012?
Provide a succinct answer. 0.59. What is the ratio of the Electricity production(% of total) in Togo in 2008 to that in 2012?
Your response must be concise. 0.36. What is the ratio of the Electricity production(% of total) of United States in 2008 to that in 2012?
Your response must be concise. 0.56. What is the ratio of the Electricity production(% of total) of Eritrea in 2009 to that in 2010?
Your response must be concise. 1.05. What is the ratio of the Electricity production(% of total) in Germany in 2009 to that in 2010?
Give a very brief answer. 0.96. What is the ratio of the Electricity production(% of total) in Togo in 2009 to that in 2010?
Make the answer very short. 1.18. What is the ratio of the Electricity production(% of total) in United States in 2009 to that in 2010?
Your answer should be compact. 0.9. What is the ratio of the Electricity production(% of total) of Eritrea in 2009 to that in 2011?
Your answer should be compact. 1.14. What is the ratio of the Electricity production(% of total) of Germany in 2009 to that in 2011?
Provide a short and direct response. 0.74. What is the ratio of the Electricity production(% of total) in Togo in 2009 to that in 2011?
Your answer should be very brief. 0.67. What is the ratio of the Electricity production(% of total) of United States in 2009 to that in 2011?
Offer a terse response. 0.77. What is the ratio of the Electricity production(% of total) of Eritrea in 2009 to that in 2012?
Keep it short and to the point. 1.22. What is the ratio of the Electricity production(% of total) in Germany in 2009 to that in 2012?
Offer a very short reply. 0.66. What is the ratio of the Electricity production(% of total) in Togo in 2009 to that in 2012?
Ensure brevity in your answer.  0.58. What is the ratio of the Electricity production(% of total) of United States in 2009 to that in 2012?
Give a very brief answer. 0.67. What is the ratio of the Electricity production(% of total) in Eritrea in 2010 to that in 2011?
Provide a succinct answer. 1.08. What is the ratio of the Electricity production(% of total) in Germany in 2010 to that in 2011?
Keep it short and to the point. 0.77. What is the ratio of the Electricity production(% of total) in Togo in 2010 to that in 2011?
Make the answer very short. 0.57. What is the ratio of the Electricity production(% of total) in United States in 2010 to that in 2011?
Keep it short and to the point. 0.86. What is the ratio of the Electricity production(% of total) in Eritrea in 2010 to that in 2012?
Provide a succinct answer. 1.15. What is the ratio of the Electricity production(% of total) of Germany in 2010 to that in 2012?
Offer a terse response. 0.69. What is the ratio of the Electricity production(% of total) of Togo in 2010 to that in 2012?
Give a very brief answer. 0.5. What is the ratio of the Electricity production(% of total) in United States in 2010 to that in 2012?
Offer a terse response. 0.75. What is the ratio of the Electricity production(% of total) in Eritrea in 2011 to that in 2012?
Provide a succinct answer. 1.07. What is the ratio of the Electricity production(% of total) in Germany in 2011 to that in 2012?
Offer a terse response. 0.9. What is the ratio of the Electricity production(% of total) of Togo in 2011 to that in 2012?
Your answer should be compact. 0.87. What is the ratio of the Electricity production(% of total) of United States in 2011 to that in 2012?
Give a very brief answer. 0.87. What is the difference between the highest and the second highest Electricity production(% of total) in Eritrea?
Offer a terse response. 0.05. What is the difference between the highest and the second highest Electricity production(% of total) of Germany?
Provide a short and direct response. 2.05. What is the difference between the highest and the second highest Electricity production(% of total) of Togo?
Provide a succinct answer. 0.6. What is the difference between the highest and the second highest Electricity production(% of total) in United States?
Your answer should be very brief. 0.69. What is the difference between the highest and the lowest Electricity production(% of total) in Eritrea?
Provide a succinct answer. 0.4. What is the difference between the highest and the lowest Electricity production(% of total) in Germany?
Make the answer very short. 12.56. What is the difference between the highest and the lowest Electricity production(% of total) in Togo?
Make the answer very short. 4.04. What is the difference between the highest and the lowest Electricity production(% of total) of United States?
Give a very brief answer. 3.29. 